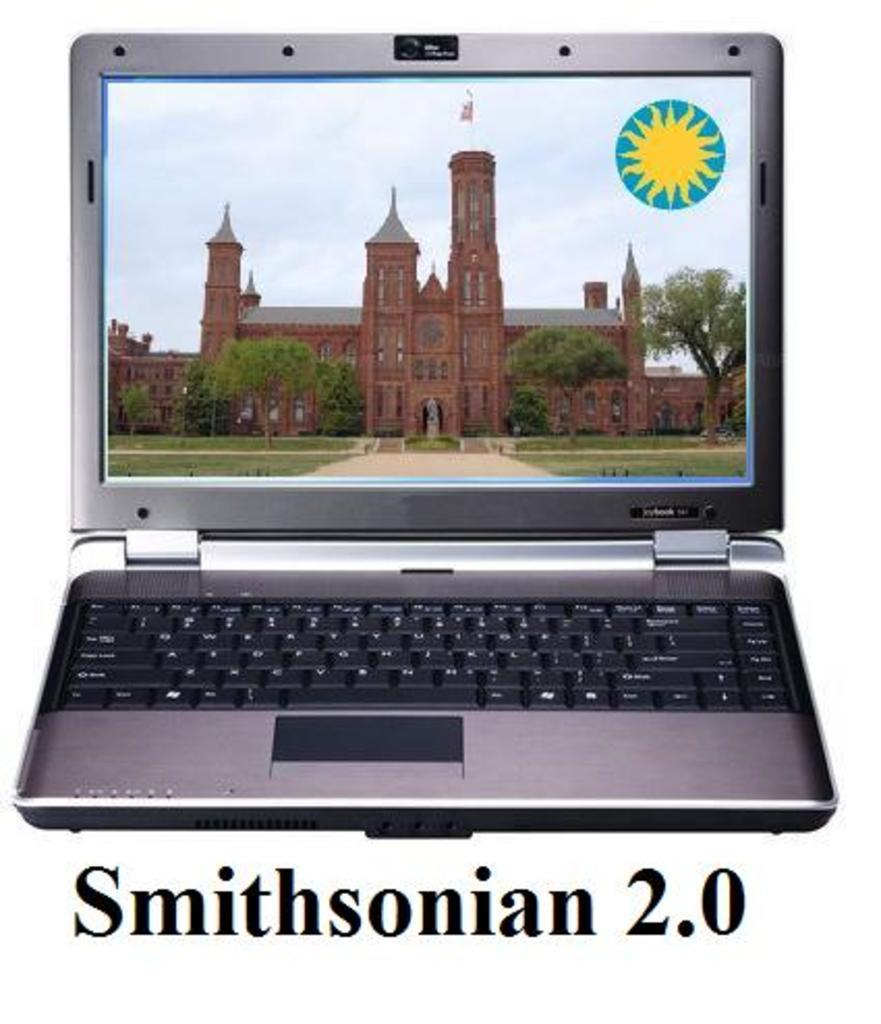<image>
Share a concise interpretation of the image provided. a computer that has Smithsonian 2.0 below it 